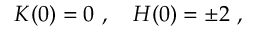Convert formula to latex. <formula><loc_0><loc_0><loc_500><loc_500>K ( 0 ) = 0 \ , \quad H ( 0 ) = \pm 2 \ ,</formula> 